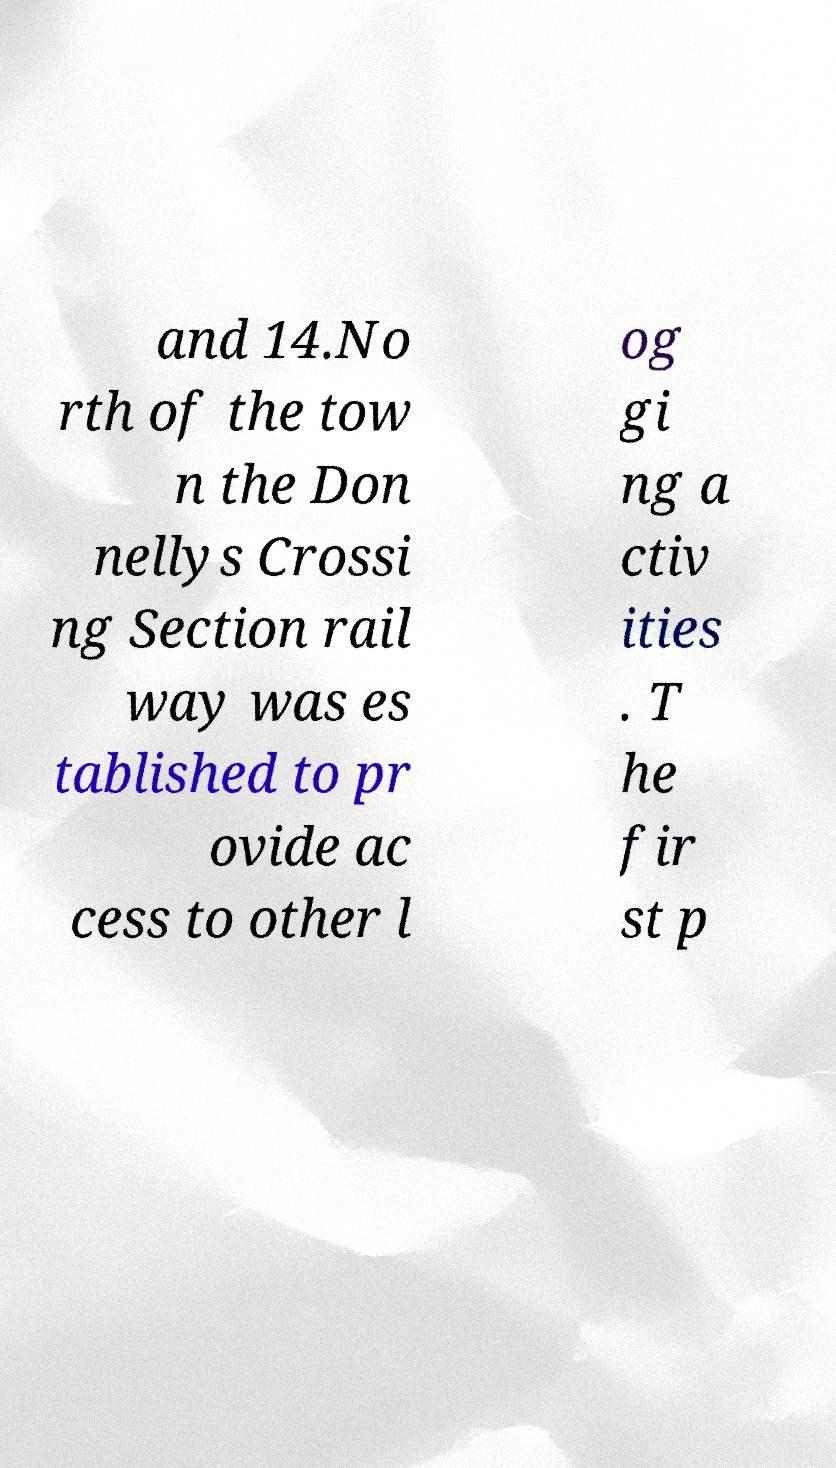Please read and relay the text visible in this image. What does it say? and 14.No rth of the tow n the Don nellys Crossi ng Section rail way was es tablished to pr ovide ac cess to other l og gi ng a ctiv ities . T he fir st p 